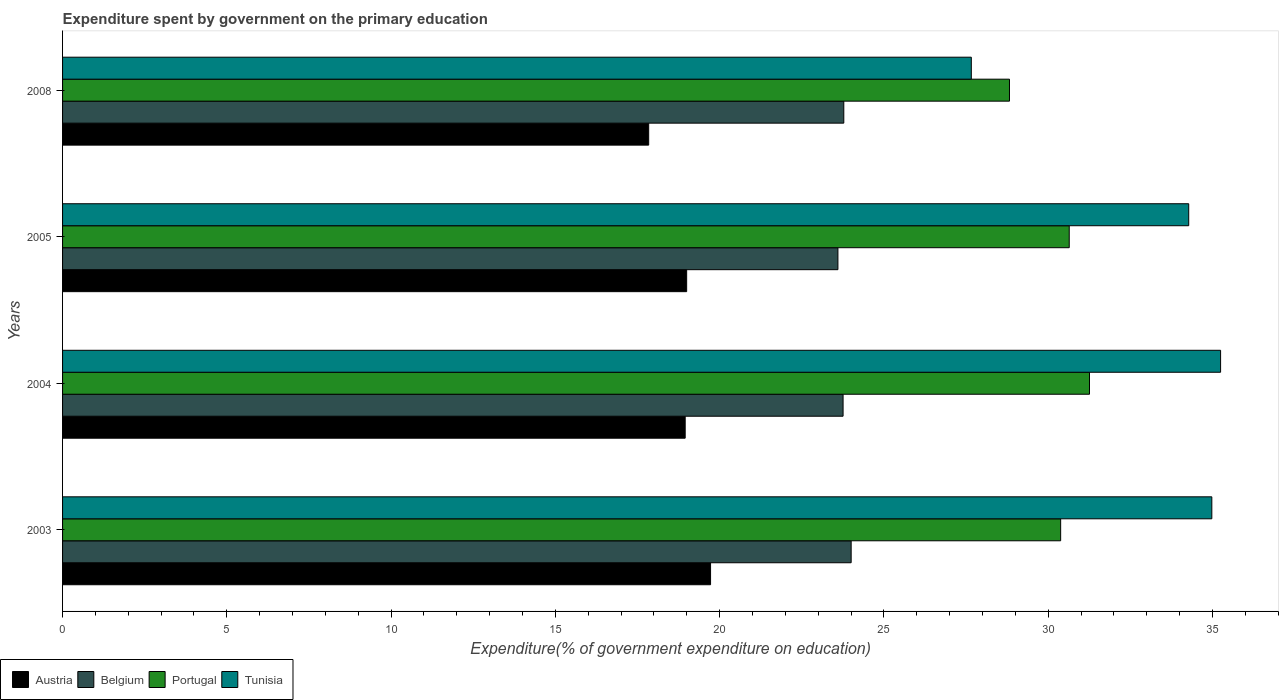How many different coloured bars are there?
Provide a short and direct response. 4. How many bars are there on the 3rd tick from the bottom?
Your answer should be very brief. 4. What is the expenditure spent by government on the primary education in Austria in 2004?
Keep it short and to the point. 18.95. Across all years, what is the maximum expenditure spent by government on the primary education in Tunisia?
Provide a succinct answer. 35.25. Across all years, what is the minimum expenditure spent by government on the primary education in Portugal?
Make the answer very short. 28.82. What is the total expenditure spent by government on the primary education in Tunisia in the graph?
Give a very brief answer. 132.16. What is the difference between the expenditure spent by government on the primary education in Belgium in 2003 and that in 2004?
Offer a very short reply. 0.25. What is the difference between the expenditure spent by government on the primary education in Austria in 2008 and the expenditure spent by government on the primary education in Tunisia in 2003?
Offer a terse response. -17.14. What is the average expenditure spent by government on the primary education in Belgium per year?
Keep it short and to the point. 23.78. In the year 2005, what is the difference between the expenditure spent by government on the primary education in Tunisia and expenditure spent by government on the primary education in Austria?
Offer a terse response. 15.28. What is the ratio of the expenditure spent by government on the primary education in Austria in 2004 to that in 2008?
Your response must be concise. 1.06. Is the expenditure spent by government on the primary education in Portugal in 2004 less than that in 2008?
Make the answer very short. No. Is the difference between the expenditure spent by government on the primary education in Tunisia in 2003 and 2005 greater than the difference between the expenditure spent by government on the primary education in Austria in 2003 and 2005?
Your answer should be very brief. No. What is the difference between the highest and the second highest expenditure spent by government on the primary education in Tunisia?
Offer a terse response. 0.27. What is the difference between the highest and the lowest expenditure spent by government on the primary education in Portugal?
Provide a short and direct response. 2.44. Is the sum of the expenditure spent by government on the primary education in Belgium in 2005 and 2008 greater than the maximum expenditure spent by government on the primary education in Portugal across all years?
Your answer should be compact. Yes. Is it the case that in every year, the sum of the expenditure spent by government on the primary education in Belgium and expenditure spent by government on the primary education in Tunisia is greater than the sum of expenditure spent by government on the primary education in Austria and expenditure spent by government on the primary education in Portugal?
Give a very brief answer. Yes. What does the 2nd bar from the top in 2004 represents?
Keep it short and to the point. Portugal. What does the 4th bar from the bottom in 2008 represents?
Provide a succinct answer. Tunisia. Is it the case that in every year, the sum of the expenditure spent by government on the primary education in Tunisia and expenditure spent by government on the primary education in Portugal is greater than the expenditure spent by government on the primary education in Belgium?
Make the answer very short. Yes. Are all the bars in the graph horizontal?
Offer a terse response. Yes. Does the graph contain any zero values?
Offer a very short reply. No. Does the graph contain grids?
Your response must be concise. No. What is the title of the graph?
Make the answer very short. Expenditure spent by government on the primary education. What is the label or title of the X-axis?
Offer a terse response. Expenditure(% of government expenditure on education). What is the Expenditure(% of government expenditure on education) of Austria in 2003?
Provide a short and direct response. 19.72. What is the Expenditure(% of government expenditure on education) of Belgium in 2003?
Provide a short and direct response. 24. What is the Expenditure(% of government expenditure on education) of Portugal in 2003?
Give a very brief answer. 30.38. What is the Expenditure(% of government expenditure on education) in Tunisia in 2003?
Provide a short and direct response. 34.98. What is the Expenditure(% of government expenditure on education) in Austria in 2004?
Offer a very short reply. 18.95. What is the Expenditure(% of government expenditure on education) of Belgium in 2004?
Keep it short and to the point. 23.76. What is the Expenditure(% of government expenditure on education) in Portugal in 2004?
Provide a succinct answer. 31.26. What is the Expenditure(% of government expenditure on education) of Tunisia in 2004?
Your answer should be compact. 35.25. What is the Expenditure(% of government expenditure on education) of Austria in 2005?
Your answer should be compact. 19. What is the Expenditure(% of government expenditure on education) in Belgium in 2005?
Keep it short and to the point. 23.6. What is the Expenditure(% of government expenditure on education) of Portugal in 2005?
Provide a succinct answer. 30.64. What is the Expenditure(% of government expenditure on education) in Tunisia in 2005?
Your response must be concise. 34.28. What is the Expenditure(% of government expenditure on education) of Austria in 2008?
Your answer should be very brief. 17.84. What is the Expenditure(% of government expenditure on education) in Belgium in 2008?
Provide a short and direct response. 23.78. What is the Expenditure(% of government expenditure on education) in Portugal in 2008?
Keep it short and to the point. 28.82. What is the Expenditure(% of government expenditure on education) of Tunisia in 2008?
Your response must be concise. 27.66. Across all years, what is the maximum Expenditure(% of government expenditure on education) in Austria?
Make the answer very short. 19.72. Across all years, what is the maximum Expenditure(% of government expenditure on education) in Belgium?
Your answer should be very brief. 24. Across all years, what is the maximum Expenditure(% of government expenditure on education) of Portugal?
Make the answer very short. 31.26. Across all years, what is the maximum Expenditure(% of government expenditure on education) in Tunisia?
Ensure brevity in your answer.  35.25. Across all years, what is the minimum Expenditure(% of government expenditure on education) of Austria?
Make the answer very short. 17.84. Across all years, what is the minimum Expenditure(% of government expenditure on education) in Belgium?
Your answer should be very brief. 23.6. Across all years, what is the minimum Expenditure(% of government expenditure on education) in Portugal?
Give a very brief answer. 28.82. Across all years, what is the minimum Expenditure(% of government expenditure on education) in Tunisia?
Your answer should be compact. 27.66. What is the total Expenditure(% of government expenditure on education) of Austria in the graph?
Give a very brief answer. 75.51. What is the total Expenditure(% of government expenditure on education) of Belgium in the graph?
Provide a short and direct response. 95.14. What is the total Expenditure(% of government expenditure on education) in Portugal in the graph?
Offer a very short reply. 121.1. What is the total Expenditure(% of government expenditure on education) of Tunisia in the graph?
Your answer should be compact. 132.16. What is the difference between the Expenditure(% of government expenditure on education) of Austria in 2003 and that in 2004?
Make the answer very short. 0.77. What is the difference between the Expenditure(% of government expenditure on education) of Belgium in 2003 and that in 2004?
Your answer should be compact. 0.25. What is the difference between the Expenditure(% of government expenditure on education) of Portugal in 2003 and that in 2004?
Give a very brief answer. -0.88. What is the difference between the Expenditure(% of government expenditure on education) of Tunisia in 2003 and that in 2004?
Your response must be concise. -0.27. What is the difference between the Expenditure(% of government expenditure on education) of Austria in 2003 and that in 2005?
Your answer should be very brief. 0.73. What is the difference between the Expenditure(% of government expenditure on education) of Belgium in 2003 and that in 2005?
Your answer should be very brief. 0.4. What is the difference between the Expenditure(% of government expenditure on education) of Portugal in 2003 and that in 2005?
Provide a short and direct response. -0.26. What is the difference between the Expenditure(% of government expenditure on education) of Tunisia in 2003 and that in 2005?
Give a very brief answer. 0.7. What is the difference between the Expenditure(% of government expenditure on education) in Austria in 2003 and that in 2008?
Make the answer very short. 1.88. What is the difference between the Expenditure(% of government expenditure on education) of Belgium in 2003 and that in 2008?
Provide a short and direct response. 0.22. What is the difference between the Expenditure(% of government expenditure on education) in Portugal in 2003 and that in 2008?
Your answer should be very brief. 1.56. What is the difference between the Expenditure(% of government expenditure on education) of Tunisia in 2003 and that in 2008?
Provide a short and direct response. 7.32. What is the difference between the Expenditure(% of government expenditure on education) of Austria in 2004 and that in 2005?
Your answer should be very brief. -0.04. What is the difference between the Expenditure(% of government expenditure on education) in Belgium in 2004 and that in 2005?
Your answer should be compact. 0.16. What is the difference between the Expenditure(% of government expenditure on education) of Portugal in 2004 and that in 2005?
Your answer should be very brief. 0.62. What is the difference between the Expenditure(% of government expenditure on education) of Tunisia in 2004 and that in 2005?
Your answer should be compact. 0.97. What is the difference between the Expenditure(% of government expenditure on education) of Austria in 2004 and that in 2008?
Your answer should be very brief. 1.11. What is the difference between the Expenditure(% of government expenditure on education) of Belgium in 2004 and that in 2008?
Make the answer very short. -0.02. What is the difference between the Expenditure(% of government expenditure on education) of Portugal in 2004 and that in 2008?
Your answer should be very brief. 2.44. What is the difference between the Expenditure(% of government expenditure on education) of Tunisia in 2004 and that in 2008?
Make the answer very short. 7.59. What is the difference between the Expenditure(% of government expenditure on education) in Austria in 2005 and that in 2008?
Offer a terse response. 1.16. What is the difference between the Expenditure(% of government expenditure on education) in Belgium in 2005 and that in 2008?
Keep it short and to the point. -0.18. What is the difference between the Expenditure(% of government expenditure on education) in Portugal in 2005 and that in 2008?
Make the answer very short. 1.82. What is the difference between the Expenditure(% of government expenditure on education) of Tunisia in 2005 and that in 2008?
Your answer should be very brief. 6.62. What is the difference between the Expenditure(% of government expenditure on education) of Austria in 2003 and the Expenditure(% of government expenditure on education) of Belgium in 2004?
Make the answer very short. -4.03. What is the difference between the Expenditure(% of government expenditure on education) in Austria in 2003 and the Expenditure(% of government expenditure on education) in Portugal in 2004?
Provide a short and direct response. -11.53. What is the difference between the Expenditure(% of government expenditure on education) in Austria in 2003 and the Expenditure(% of government expenditure on education) in Tunisia in 2004?
Your answer should be very brief. -15.52. What is the difference between the Expenditure(% of government expenditure on education) in Belgium in 2003 and the Expenditure(% of government expenditure on education) in Portugal in 2004?
Make the answer very short. -7.25. What is the difference between the Expenditure(% of government expenditure on education) of Belgium in 2003 and the Expenditure(% of government expenditure on education) of Tunisia in 2004?
Provide a succinct answer. -11.24. What is the difference between the Expenditure(% of government expenditure on education) of Portugal in 2003 and the Expenditure(% of government expenditure on education) of Tunisia in 2004?
Your response must be concise. -4.87. What is the difference between the Expenditure(% of government expenditure on education) in Austria in 2003 and the Expenditure(% of government expenditure on education) in Belgium in 2005?
Ensure brevity in your answer.  -3.88. What is the difference between the Expenditure(% of government expenditure on education) in Austria in 2003 and the Expenditure(% of government expenditure on education) in Portugal in 2005?
Make the answer very short. -10.92. What is the difference between the Expenditure(% of government expenditure on education) of Austria in 2003 and the Expenditure(% of government expenditure on education) of Tunisia in 2005?
Your answer should be very brief. -14.55. What is the difference between the Expenditure(% of government expenditure on education) of Belgium in 2003 and the Expenditure(% of government expenditure on education) of Portugal in 2005?
Your answer should be very brief. -6.64. What is the difference between the Expenditure(% of government expenditure on education) of Belgium in 2003 and the Expenditure(% of government expenditure on education) of Tunisia in 2005?
Make the answer very short. -10.27. What is the difference between the Expenditure(% of government expenditure on education) in Portugal in 2003 and the Expenditure(% of government expenditure on education) in Tunisia in 2005?
Offer a terse response. -3.9. What is the difference between the Expenditure(% of government expenditure on education) in Austria in 2003 and the Expenditure(% of government expenditure on education) in Belgium in 2008?
Ensure brevity in your answer.  -4.06. What is the difference between the Expenditure(% of government expenditure on education) of Austria in 2003 and the Expenditure(% of government expenditure on education) of Portugal in 2008?
Offer a very short reply. -9.1. What is the difference between the Expenditure(% of government expenditure on education) of Austria in 2003 and the Expenditure(% of government expenditure on education) of Tunisia in 2008?
Offer a terse response. -7.94. What is the difference between the Expenditure(% of government expenditure on education) in Belgium in 2003 and the Expenditure(% of government expenditure on education) in Portugal in 2008?
Make the answer very short. -4.82. What is the difference between the Expenditure(% of government expenditure on education) of Belgium in 2003 and the Expenditure(% of government expenditure on education) of Tunisia in 2008?
Make the answer very short. -3.66. What is the difference between the Expenditure(% of government expenditure on education) in Portugal in 2003 and the Expenditure(% of government expenditure on education) in Tunisia in 2008?
Your answer should be compact. 2.72. What is the difference between the Expenditure(% of government expenditure on education) in Austria in 2004 and the Expenditure(% of government expenditure on education) in Belgium in 2005?
Give a very brief answer. -4.65. What is the difference between the Expenditure(% of government expenditure on education) in Austria in 2004 and the Expenditure(% of government expenditure on education) in Portugal in 2005?
Your answer should be very brief. -11.69. What is the difference between the Expenditure(% of government expenditure on education) of Austria in 2004 and the Expenditure(% of government expenditure on education) of Tunisia in 2005?
Ensure brevity in your answer.  -15.33. What is the difference between the Expenditure(% of government expenditure on education) of Belgium in 2004 and the Expenditure(% of government expenditure on education) of Portugal in 2005?
Make the answer very short. -6.88. What is the difference between the Expenditure(% of government expenditure on education) in Belgium in 2004 and the Expenditure(% of government expenditure on education) in Tunisia in 2005?
Ensure brevity in your answer.  -10.52. What is the difference between the Expenditure(% of government expenditure on education) in Portugal in 2004 and the Expenditure(% of government expenditure on education) in Tunisia in 2005?
Your answer should be compact. -3.02. What is the difference between the Expenditure(% of government expenditure on education) in Austria in 2004 and the Expenditure(% of government expenditure on education) in Belgium in 2008?
Keep it short and to the point. -4.83. What is the difference between the Expenditure(% of government expenditure on education) in Austria in 2004 and the Expenditure(% of government expenditure on education) in Portugal in 2008?
Offer a very short reply. -9.87. What is the difference between the Expenditure(% of government expenditure on education) in Austria in 2004 and the Expenditure(% of government expenditure on education) in Tunisia in 2008?
Keep it short and to the point. -8.71. What is the difference between the Expenditure(% of government expenditure on education) of Belgium in 2004 and the Expenditure(% of government expenditure on education) of Portugal in 2008?
Ensure brevity in your answer.  -5.06. What is the difference between the Expenditure(% of government expenditure on education) of Belgium in 2004 and the Expenditure(% of government expenditure on education) of Tunisia in 2008?
Your response must be concise. -3.9. What is the difference between the Expenditure(% of government expenditure on education) in Portugal in 2004 and the Expenditure(% of government expenditure on education) in Tunisia in 2008?
Provide a short and direct response. 3.6. What is the difference between the Expenditure(% of government expenditure on education) in Austria in 2005 and the Expenditure(% of government expenditure on education) in Belgium in 2008?
Your answer should be compact. -4.78. What is the difference between the Expenditure(% of government expenditure on education) in Austria in 2005 and the Expenditure(% of government expenditure on education) in Portugal in 2008?
Your answer should be very brief. -9.83. What is the difference between the Expenditure(% of government expenditure on education) of Austria in 2005 and the Expenditure(% of government expenditure on education) of Tunisia in 2008?
Offer a terse response. -8.66. What is the difference between the Expenditure(% of government expenditure on education) in Belgium in 2005 and the Expenditure(% of government expenditure on education) in Portugal in 2008?
Offer a very short reply. -5.22. What is the difference between the Expenditure(% of government expenditure on education) in Belgium in 2005 and the Expenditure(% of government expenditure on education) in Tunisia in 2008?
Offer a terse response. -4.06. What is the difference between the Expenditure(% of government expenditure on education) of Portugal in 2005 and the Expenditure(% of government expenditure on education) of Tunisia in 2008?
Provide a succinct answer. 2.98. What is the average Expenditure(% of government expenditure on education) of Austria per year?
Make the answer very short. 18.88. What is the average Expenditure(% of government expenditure on education) of Belgium per year?
Keep it short and to the point. 23.78. What is the average Expenditure(% of government expenditure on education) of Portugal per year?
Offer a very short reply. 30.27. What is the average Expenditure(% of government expenditure on education) of Tunisia per year?
Ensure brevity in your answer.  33.04. In the year 2003, what is the difference between the Expenditure(% of government expenditure on education) in Austria and Expenditure(% of government expenditure on education) in Belgium?
Offer a terse response. -4.28. In the year 2003, what is the difference between the Expenditure(% of government expenditure on education) of Austria and Expenditure(% of government expenditure on education) of Portugal?
Your answer should be compact. -10.66. In the year 2003, what is the difference between the Expenditure(% of government expenditure on education) in Austria and Expenditure(% of government expenditure on education) in Tunisia?
Give a very brief answer. -15.26. In the year 2003, what is the difference between the Expenditure(% of government expenditure on education) in Belgium and Expenditure(% of government expenditure on education) in Portugal?
Your response must be concise. -6.38. In the year 2003, what is the difference between the Expenditure(% of government expenditure on education) in Belgium and Expenditure(% of government expenditure on education) in Tunisia?
Give a very brief answer. -10.98. In the year 2003, what is the difference between the Expenditure(% of government expenditure on education) in Portugal and Expenditure(% of government expenditure on education) in Tunisia?
Offer a terse response. -4.6. In the year 2004, what is the difference between the Expenditure(% of government expenditure on education) of Austria and Expenditure(% of government expenditure on education) of Belgium?
Offer a very short reply. -4.81. In the year 2004, what is the difference between the Expenditure(% of government expenditure on education) of Austria and Expenditure(% of government expenditure on education) of Portugal?
Keep it short and to the point. -12.31. In the year 2004, what is the difference between the Expenditure(% of government expenditure on education) in Austria and Expenditure(% of government expenditure on education) in Tunisia?
Keep it short and to the point. -16.3. In the year 2004, what is the difference between the Expenditure(% of government expenditure on education) of Belgium and Expenditure(% of government expenditure on education) of Tunisia?
Provide a succinct answer. -11.49. In the year 2004, what is the difference between the Expenditure(% of government expenditure on education) in Portugal and Expenditure(% of government expenditure on education) in Tunisia?
Make the answer very short. -3.99. In the year 2005, what is the difference between the Expenditure(% of government expenditure on education) of Austria and Expenditure(% of government expenditure on education) of Belgium?
Give a very brief answer. -4.6. In the year 2005, what is the difference between the Expenditure(% of government expenditure on education) of Austria and Expenditure(% of government expenditure on education) of Portugal?
Your answer should be compact. -11.64. In the year 2005, what is the difference between the Expenditure(% of government expenditure on education) in Austria and Expenditure(% of government expenditure on education) in Tunisia?
Provide a succinct answer. -15.28. In the year 2005, what is the difference between the Expenditure(% of government expenditure on education) of Belgium and Expenditure(% of government expenditure on education) of Portugal?
Your response must be concise. -7.04. In the year 2005, what is the difference between the Expenditure(% of government expenditure on education) in Belgium and Expenditure(% of government expenditure on education) in Tunisia?
Provide a short and direct response. -10.68. In the year 2005, what is the difference between the Expenditure(% of government expenditure on education) in Portugal and Expenditure(% of government expenditure on education) in Tunisia?
Ensure brevity in your answer.  -3.64. In the year 2008, what is the difference between the Expenditure(% of government expenditure on education) of Austria and Expenditure(% of government expenditure on education) of Belgium?
Your answer should be very brief. -5.94. In the year 2008, what is the difference between the Expenditure(% of government expenditure on education) in Austria and Expenditure(% of government expenditure on education) in Portugal?
Your response must be concise. -10.98. In the year 2008, what is the difference between the Expenditure(% of government expenditure on education) in Austria and Expenditure(% of government expenditure on education) in Tunisia?
Offer a terse response. -9.82. In the year 2008, what is the difference between the Expenditure(% of government expenditure on education) in Belgium and Expenditure(% of government expenditure on education) in Portugal?
Your answer should be very brief. -5.04. In the year 2008, what is the difference between the Expenditure(% of government expenditure on education) of Belgium and Expenditure(% of government expenditure on education) of Tunisia?
Ensure brevity in your answer.  -3.88. In the year 2008, what is the difference between the Expenditure(% of government expenditure on education) of Portugal and Expenditure(% of government expenditure on education) of Tunisia?
Make the answer very short. 1.16. What is the ratio of the Expenditure(% of government expenditure on education) in Austria in 2003 to that in 2004?
Provide a succinct answer. 1.04. What is the ratio of the Expenditure(% of government expenditure on education) of Belgium in 2003 to that in 2004?
Keep it short and to the point. 1.01. What is the ratio of the Expenditure(% of government expenditure on education) in Portugal in 2003 to that in 2004?
Offer a terse response. 0.97. What is the ratio of the Expenditure(% of government expenditure on education) of Tunisia in 2003 to that in 2004?
Give a very brief answer. 0.99. What is the ratio of the Expenditure(% of government expenditure on education) of Austria in 2003 to that in 2005?
Provide a short and direct response. 1.04. What is the ratio of the Expenditure(% of government expenditure on education) of Belgium in 2003 to that in 2005?
Keep it short and to the point. 1.02. What is the ratio of the Expenditure(% of government expenditure on education) of Tunisia in 2003 to that in 2005?
Your answer should be compact. 1.02. What is the ratio of the Expenditure(% of government expenditure on education) of Austria in 2003 to that in 2008?
Offer a terse response. 1.11. What is the ratio of the Expenditure(% of government expenditure on education) of Belgium in 2003 to that in 2008?
Keep it short and to the point. 1.01. What is the ratio of the Expenditure(% of government expenditure on education) of Portugal in 2003 to that in 2008?
Provide a short and direct response. 1.05. What is the ratio of the Expenditure(% of government expenditure on education) of Tunisia in 2003 to that in 2008?
Offer a very short reply. 1.26. What is the ratio of the Expenditure(% of government expenditure on education) of Belgium in 2004 to that in 2005?
Your answer should be very brief. 1.01. What is the ratio of the Expenditure(% of government expenditure on education) of Portugal in 2004 to that in 2005?
Provide a succinct answer. 1.02. What is the ratio of the Expenditure(% of government expenditure on education) in Tunisia in 2004 to that in 2005?
Offer a terse response. 1.03. What is the ratio of the Expenditure(% of government expenditure on education) in Austria in 2004 to that in 2008?
Ensure brevity in your answer.  1.06. What is the ratio of the Expenditure(% of government expenditure on education) of Portugal in 2004 to that in 2008?
Offer a very short reply. 1.08. What is the ratio of the Expenditure(% of government expenditure on education) in Tunisia in 2004 to that in 2008?
Ensure brevity in your answer.  1.27. What is the ratio of the Expenditure(% of government expenditure on education) in Austria in 2005 to that in 2008?
Provide a short and direct response. 1.06. What is the ratio of the Expenditure(% of government expenditure on education) of Belgium in 2005 to that in 2008?
Your answer should be very brief. 0.99. What is the ratio of the Expenditure(% of government expenditure on education) in Portugal in 2005 to that in 2008?
Your answer should be compact. 1.06. What is the ratio of the Expenditure(% of government expenditure on education) of Tunisia in 2005 to that in 2008?
Make the answer very short. 1.24. What is the difference between the highest and the second highest Expenditure(% of government expenditure on education) of Austria?
Your answer should be compact. 0.73. What is the difference between the highest and the second highest Expenditure(% of government expenditure on education) of Belgium?
Keep it short and to the point. 0.22. What is the difference between the highest and the second highest Expenditure(% of government expenditure on education) of Portugal?
Your answer should be compact. 0.62. What is the difference between the highest and the second highest Expenditure(% of government expenditure on education) in Tunisia?
Offer a terse response. 0.27. What is the difference between the highest and the lowest Expenditure(% of government expenditure on education) of Austria?
Make the answer very short. 1.88. What is the difference between the highest and the lowest Expenditure(% of government expenditure on education) of Belgium?
Make the answer very short. 0.4. What is the difference between the highest and the lowest Expenditure(% of government expenditure on education) in Portugal?
Offer a very short reply. 2.44. What is the difference between the highest and the lowest Expenditure(% of government expenditure on education) of Tunisia?
Your answer should be compact. 7.59. 